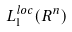Convert formula to latex. <formula><loc_0><loc_0><loc_500><loc_500>L _ { 1 } ^ { l o c } ( R ^ { n } )</formula> 